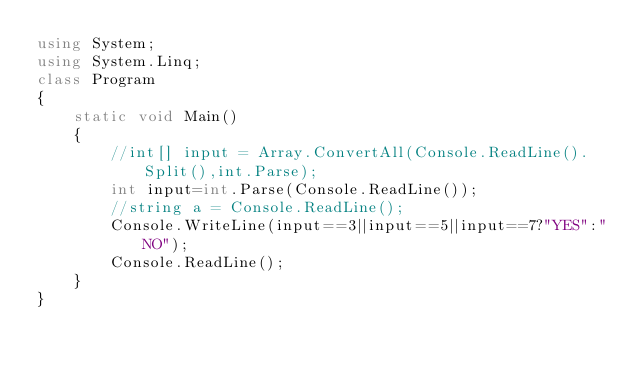Convert code to text. <code><loc_0><loc_0><loc_500><loc_500><_C#_>using System;
using System.Linq;
class Program
{
    static void Main()
    {
        //int[] input = Array.ConvertAll(Console.ReadLine().Split(),int.Parse);
        int input=int.Parse(Console.ReadLine());
        //string a = Console.ReadLine();
        Console.WriteLine(input==3||input==5||input==7?"YES":"NO");
        Console.ReadLine();
    }
}
</code> 